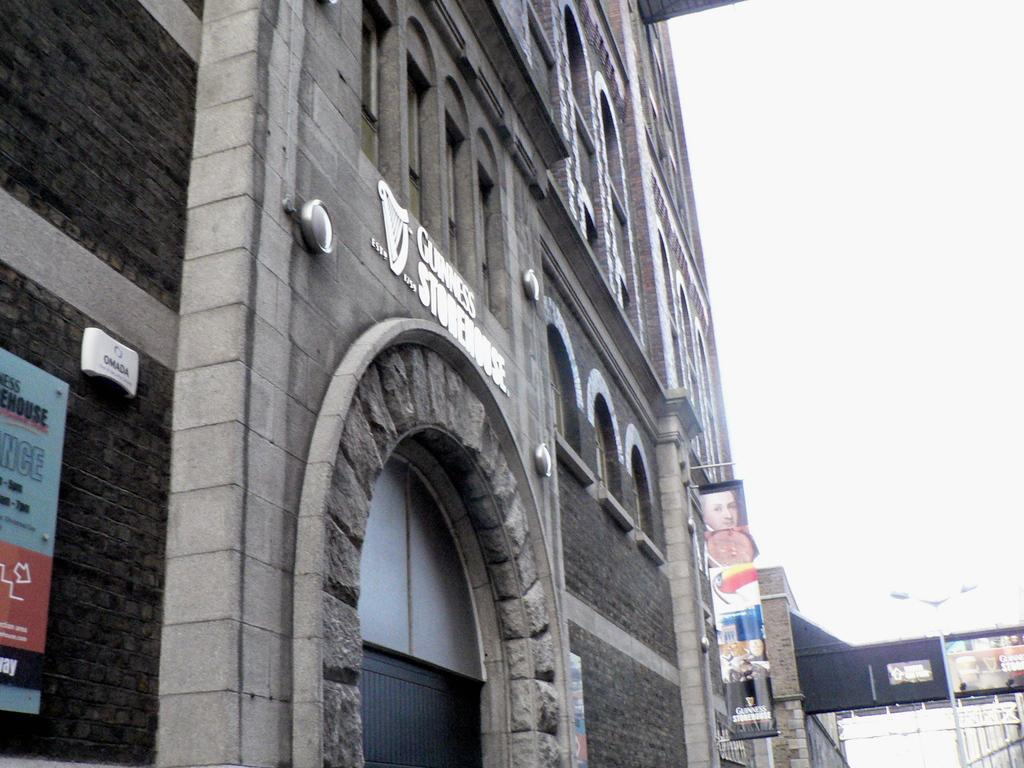What type of structure is present in the image? There is a building in the image. Can you describe the surroundings of the first building? There is another building near the first one. What feature can be seen on the second building? The second building has a pole with lights. What can be seen in the distance in the image? The sky is visible in the background of the image. What type of news is being broadcasted from the pole with lights on the second building? There is no indication in the image that news is being broadcasted from the pole with lights on the second building. 